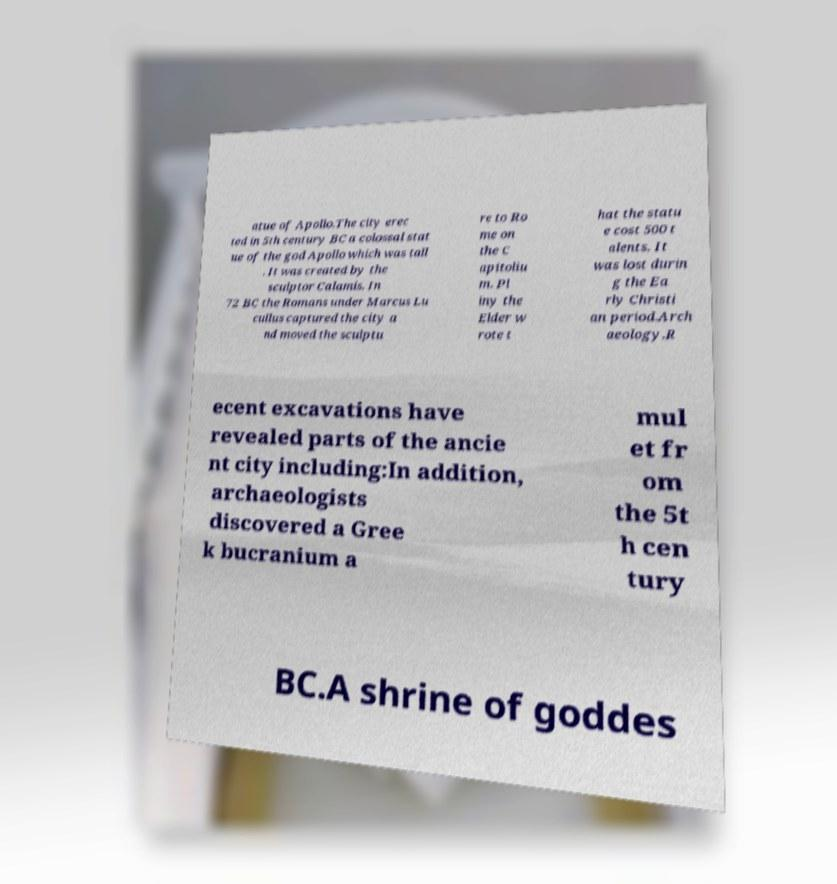Please read and relay the text visible in this image. What does it say? atue of Apollo.The city erec ted in 5th century BC a colossal stat ue of the god Apollo which was tall . It was created by the sculptor Calamis. In 72 BC the Romans under Marcus Lu cullus captured the city a nd moved the sculptu re to Ro me on the C apitoliu m. Pl iny the Elder w rote t hat the statu e cost 500 t alents. It was lost durin g the Ea rly Christi an period.Arch aeology.R ecent excavations have revealed parts of the ancie nt city including:In addition, archaeologists discovered a Gree k bucranium a mul et fr om the 5t h cen tury BC.A shrine of goddes 